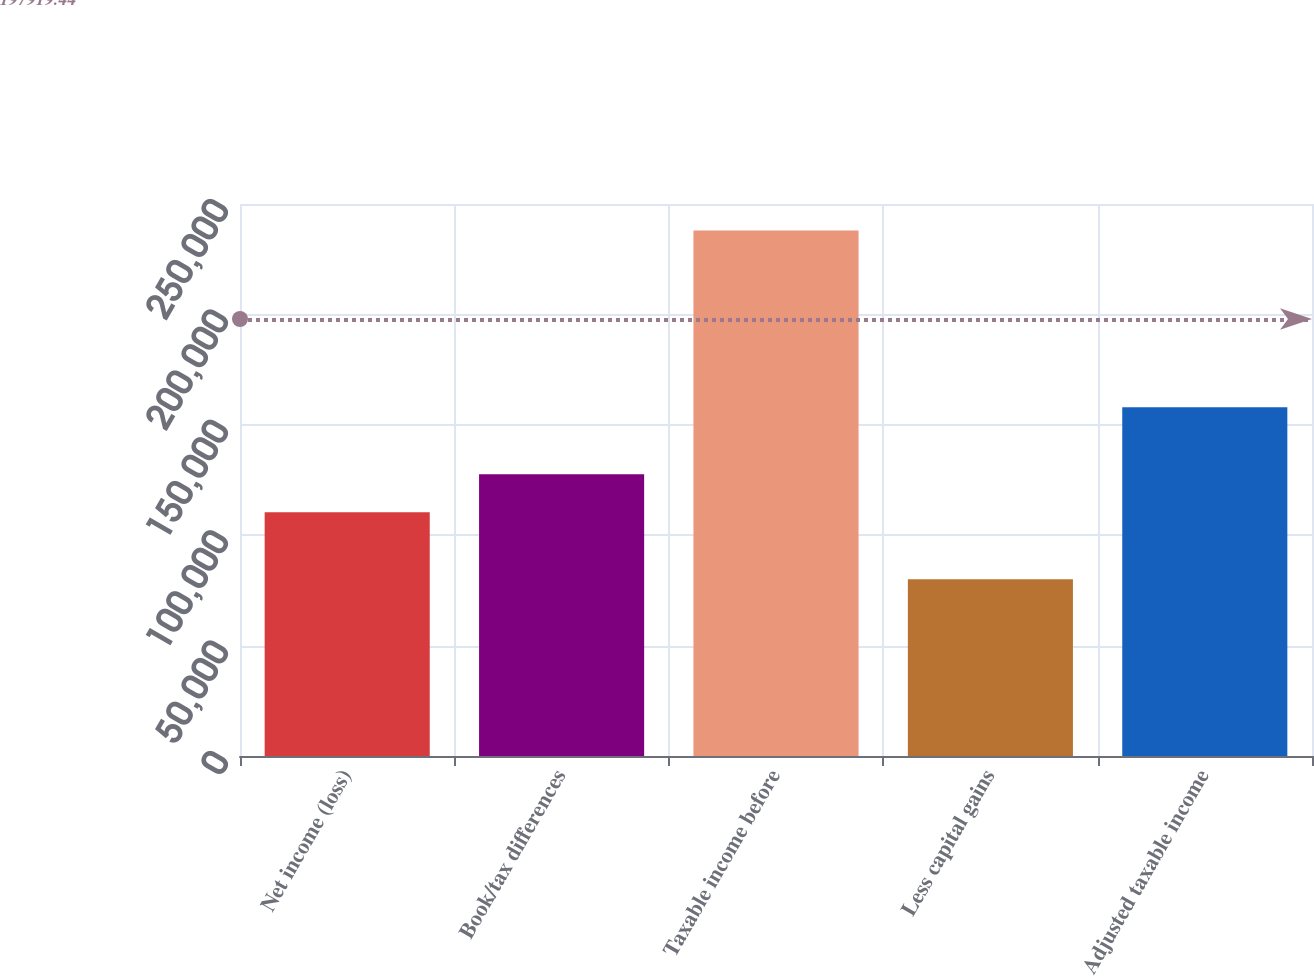<chart> <loc_0><loc_0><loc_500><loc_500><bar_chart><fcel>Net income (loss)<fcel>Book/tax differences<fcel>Taxable income before<fcel>Less capital gains<fcel>Adjusted taxable income<nl><fcel>110408<fcel>127607<fcel>238015<fcel>80069<fcel>157946<nl></chart> 